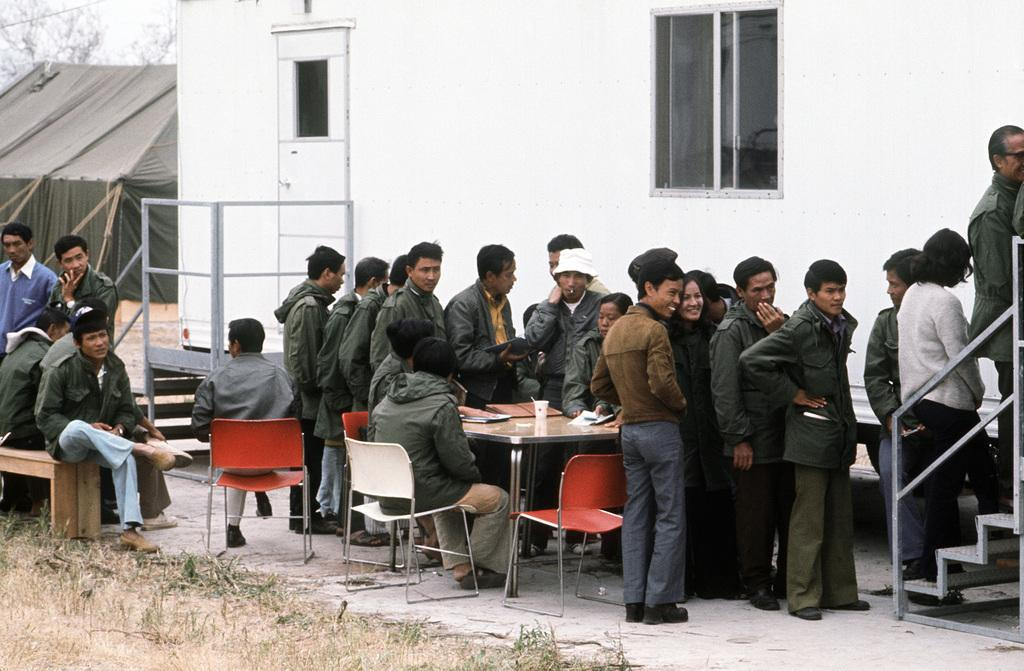How many people are in the image? There is a group of people in the image, but the exact number is not specified. What are the people in the image doing? Some people are standing, and some are sitting on chairs. What can be seen in the background of the image? There is a tree, sky, window, and wall visible in the background of the image. What type of ship can be seen sailing in the background of the image? There is no ship visible in the image; it only features a tree, sky, window, and wall in the background. What color is the hair of the person sitting on the chair in the image? The image does not provide information about the hair color of any person in the image. 